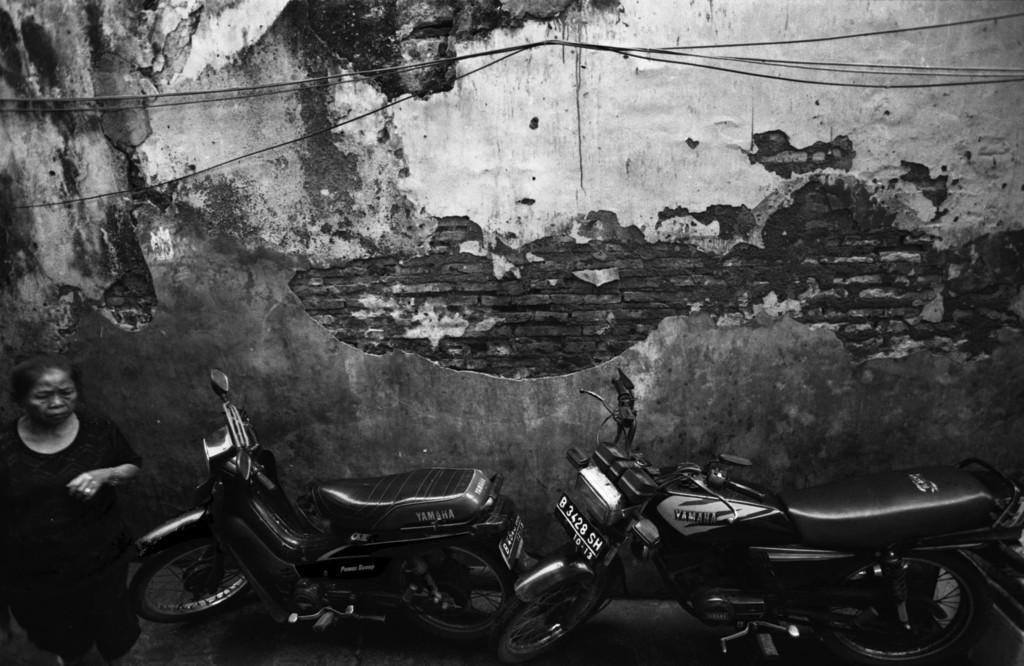How would you summarize this image in a sentence or two? In this picture I can see some vehicles, women are standing in front of the wall. 